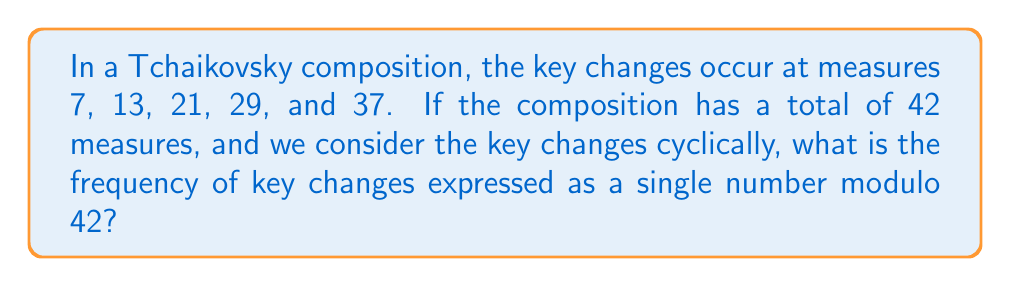Can you answer this question? Let's approach this step-by-step:

1) First, we need to calculate the intervals between key changes:
   $$(13-7, 21-13, 29-21, 37-29, 42-37+7)$$
   $$(6, 8, 8, 8, 12)$$

2) Now, we need to find the greatest common divisor (GCD) of these intervals and the total number of measures. We can use the Euclidean algorithm:

   $$GCD(6, 8, 8, 8, 12, 42) = GCD(6, 2, 42) = GCD(6, 2) = 2$$

3) The frequency of key changes can be expressed as the inverse of this GCD modulo 42:

   We need to find $x$ such that $2x \equiv 1 \pmod{42}$

4) We can use the extended Euclidean algorithm:
   
   $42 = 21 \cdot 2 + 0$
   
   $2x + 42y = 1$
   $2x - 1 = -42y$
   $2x \equiv 1 \pmod{42}$
   $x \equiv 21 \pmod{42}$ (since $2 \cdot 21 = 42 \equiv 0 \pmod{42}$)

5) Therefore, the frequency of key changes is 21 modulo 42.
Answer: 21 